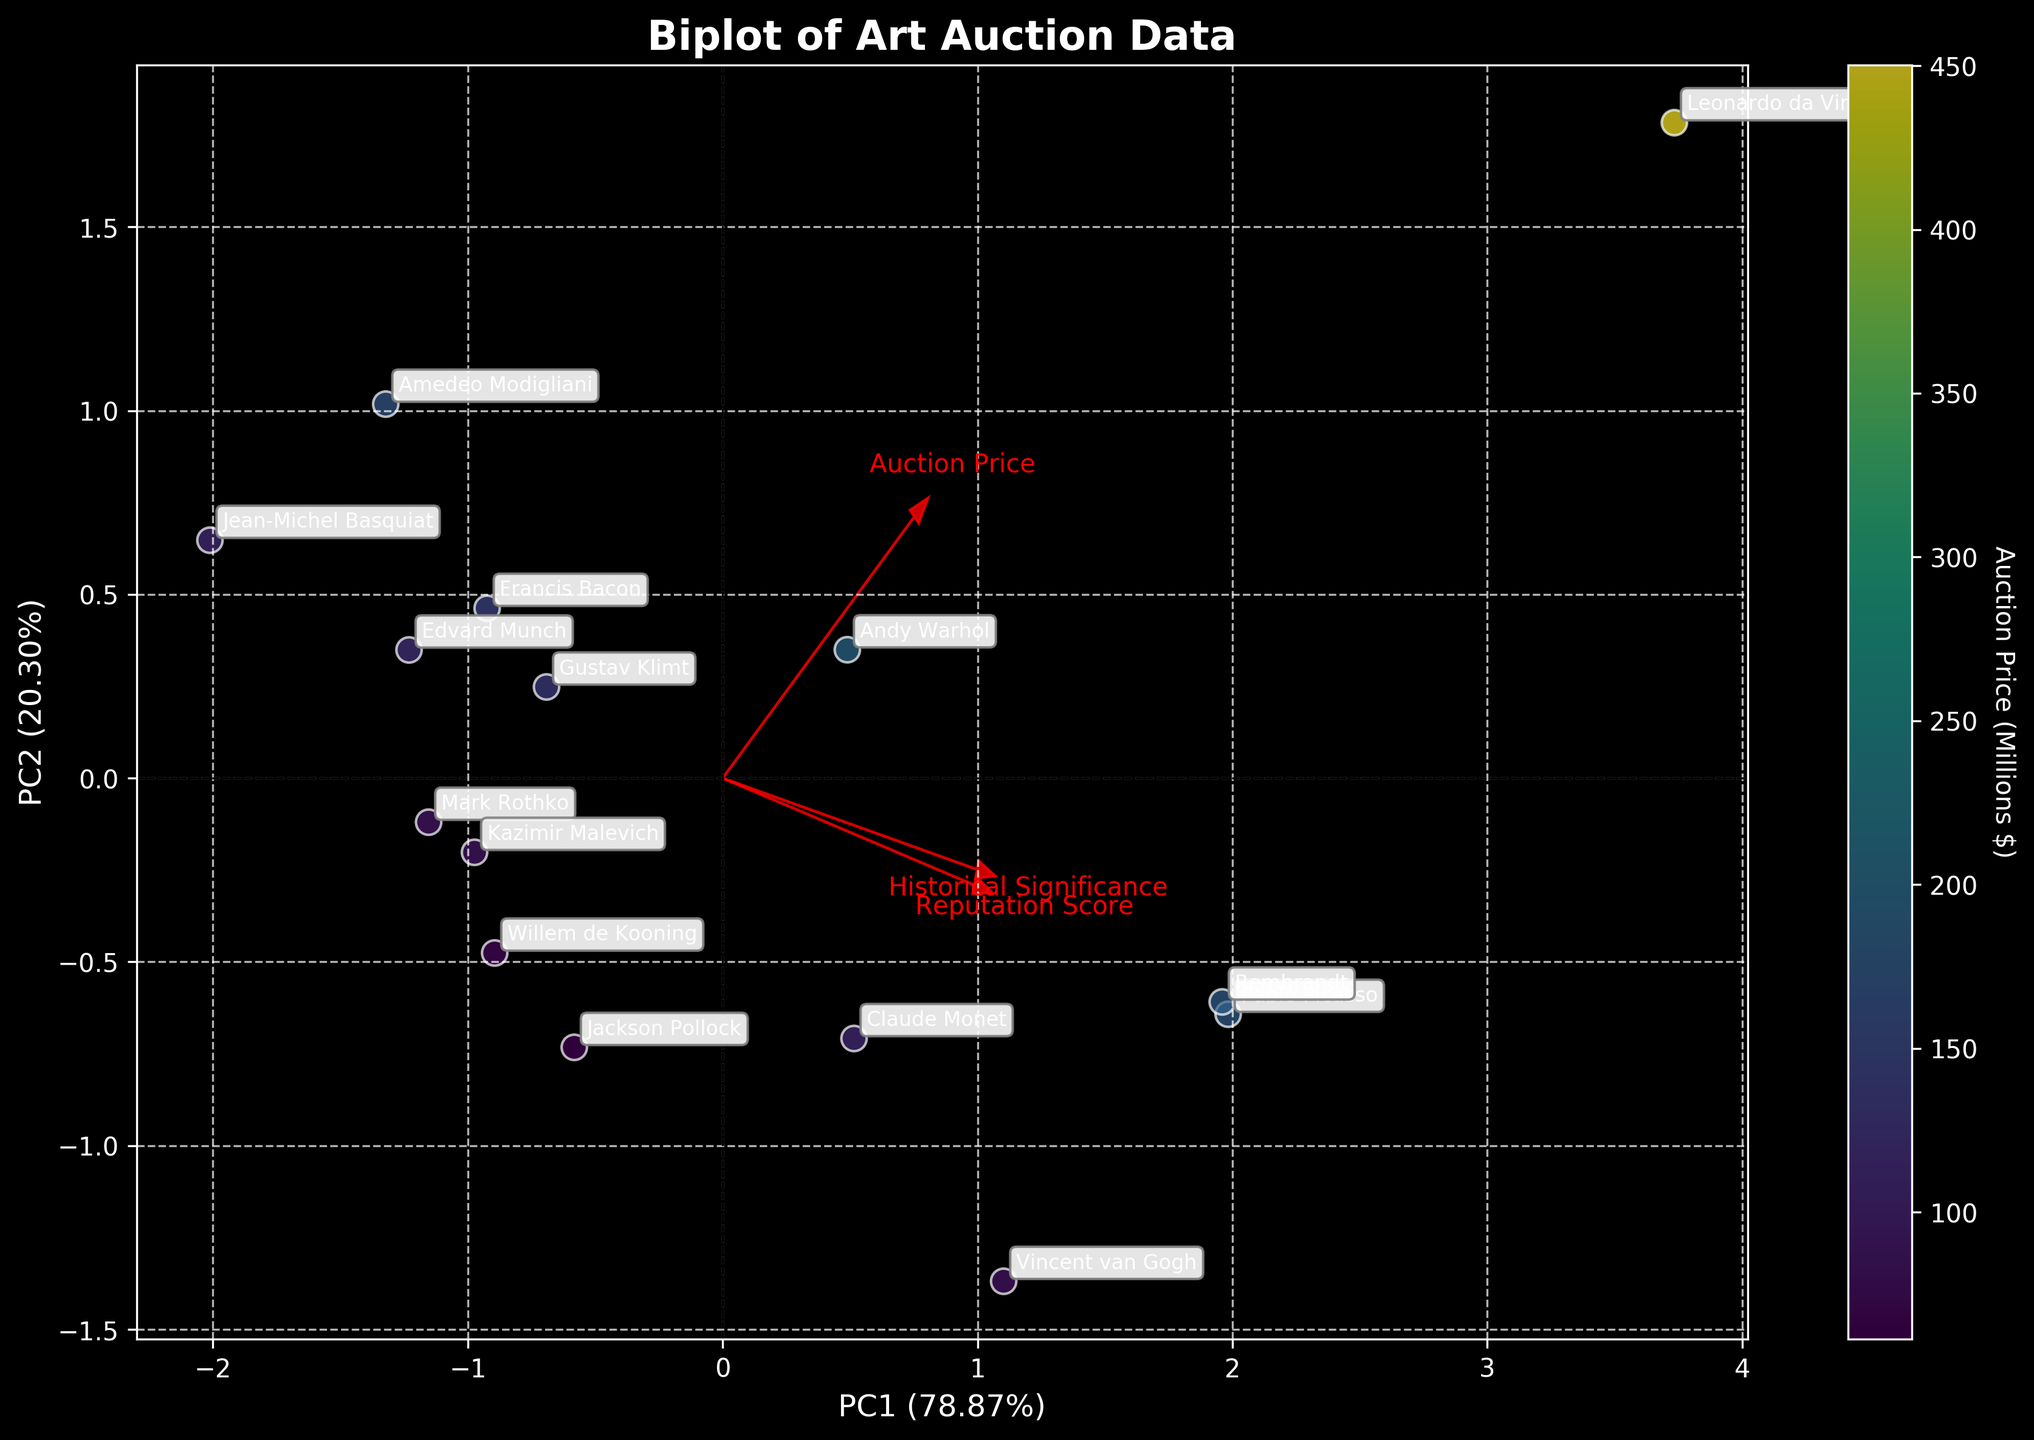How many artists are represented in the plot? Count the number of distinct artist names shown in the annotations on the plot. Each artist name represents a data point.
Answer: 15 What is the overall theme of the plot? The title of the plot indicates its theme. Look at the top of the plot to identify this information.
Answer: Examination of art auction prices in relation to historical significance and artist reputation Which artist has the highest auction price, and where is this data point located in the plot? Identify the artist with the highest auction price from the annotations and use the color scale (colorbar) to pinpoint this data point. Leonardo da Vinci's point will have the highest value on the colorbar.
Answer: Leonardo da Vinci (located at the point with the deepest color) What are the labels on the x and y axes, and what do they represent? Examine the text along the horizontal (x-axis) and vertical (y-axis) lines. These labels explain what each axis represents in the plot.
Answer: PC1 (% variance explained) and PC2 (% variance explained) Which variable has the largest loading on PC1? Look at the red arrows denoting loadings. Identify the longest arrow along the horizontal direction (PC1 axis). This arrow signifies the strongest variable influencing PC1.
Answer: Historical Significance Which artist has a higher reputation score: Jackson Pollock or Willem de Kooning? Locate the points for Jackson Pollock and Willem de Kooning using the annotations, then compare their positions in relation to the red arrow labeled "Reputation Score". The point farther in the direction of this arrow indicates a higher score.
Answer: Jackson Pollock Of the provided variables, which shows the lowest influence on PC2? Determine which red arrow has the smallest projection along the vertical direction (PC2 axis). The shortest vertical arrow indicates the least influence on PC2.
Answer: Reputation Score Who is closer to Picasso in the plot: Claude Monet or Andy Warhol? Identify and compare the distances between the points for Picasso, Claude Monet, and Andy Warhol using the annotated names. Determine which point is spatially nearer to Picasso.
Answer: Andy Warhol Can Edvard Munch's auction price be considered among the top five? Use the color scale and annotated values to judge if Edvard Munch’s auction price is among the top five highest prices presented in the plot, referring to the color depth as an indicator.
Answer: No Which principal component explains more variance, and what percentage of the total variance does it explain? Check the labels on the x and y axes which have the percentage of variance explained by PC1 and PC2. The higher percentage indicates the principal component that explains more variance.
Answer: PC1 (% explained); Specific percentage shown on x-axis (dependent on plot output) 